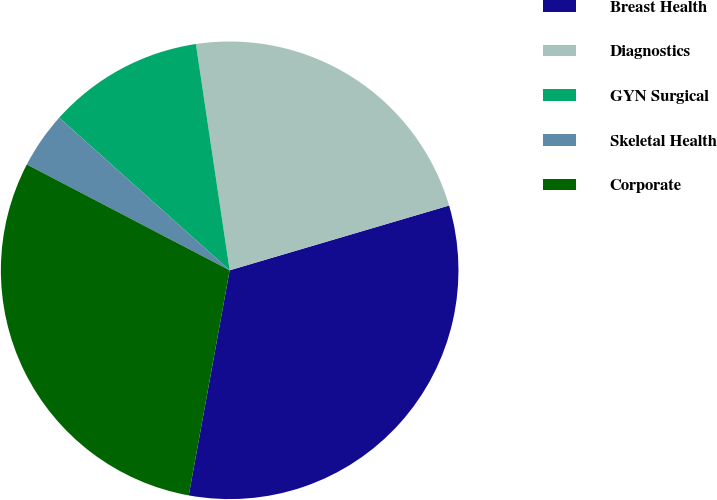Convert chart. <chart><loc_0><loc_0><loc_500><loc_500><pie_chart><fcel>Breast Health<fcel>Diagnostics<fcel>GYN Surgical<fcel>Skeletal Health<fcel>Corporate<nl><fcel>32.43%<fcel>22.79%<fcel>11.02%<fcel>3.97%<fcel>29.79%<nl></chart> 